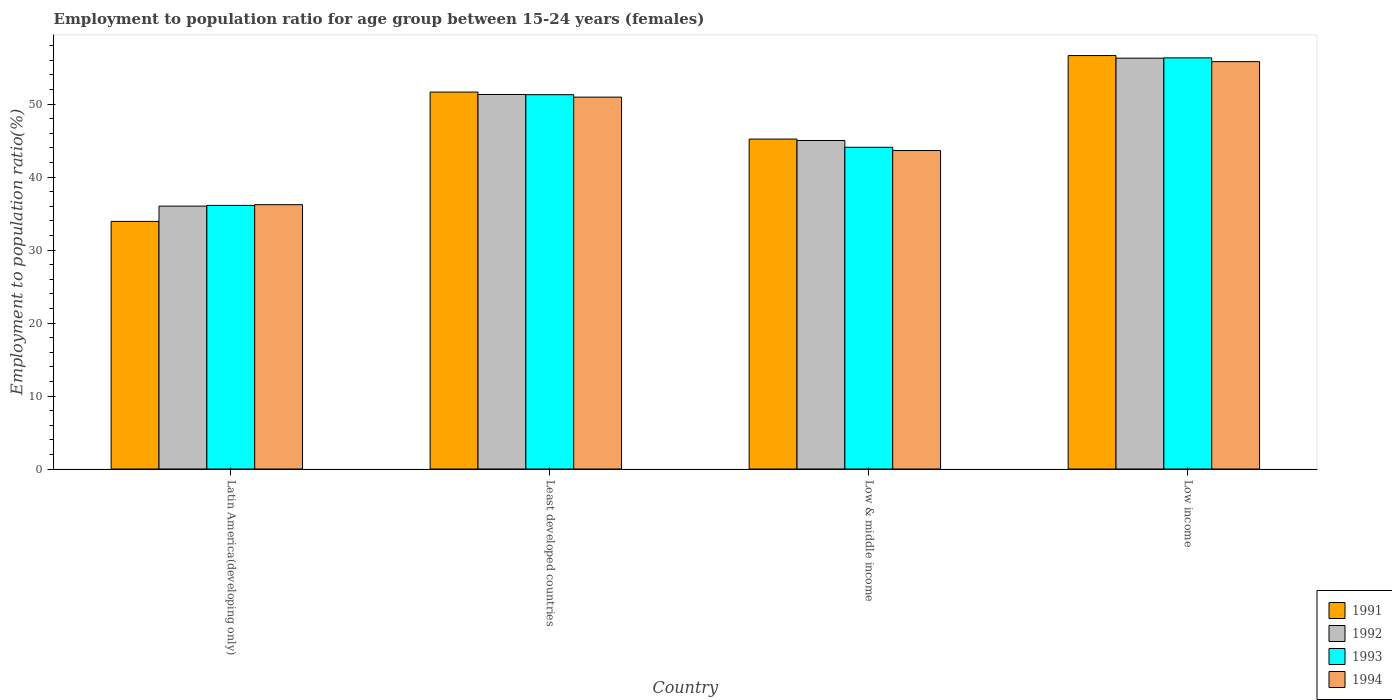What is the label of the 1st group of bars from the left?
Make the answer very short. Latin America(developing only). What is the employment to population ratio in 1993 in Low income?
Provide a succinct answer. 56.33. Across all countries, what is the maximum employment to population ratio in 1994?
Make the answer very short. 55.82. Across all countries, what is the minimum employment to population ratio in 1994?
Your answer should be compact. 36.22. In which country was the employment to population ratio in 1992 maximum?
Your answer should be compact. Low income. In which country was the employment to population ratio in 1994 minimum?
Your answer should be compact. Latin America(developing only). What is the total employment to population ratio in 1994 in the graph?
Offer a terse response. 186.64. What is the difference between the employment to population ratio in 1991 in Latin America(developing only) and that in Low income?
Give a very brief answer. -22.73. What is the difference between the employment to population ratio in 1994 in Least developed countries and the employment to population ratio in 1992 in Latin America(developing only)?
Your answer should be very brief. 14.93. What is the average employment to population ratio in 1993 per country?
Offer a terse response. 46.96. What is the difference between the employment to population ratio of/in 1992 and employment to population ratio of/in 1994 in Low income?
Provide a short and direct response. 0.47. What is the ratio of the employment to population ratio in 1994 in Latin America(developing only) to that in Low & middle income?
Your response must be concise. 0.83. Is the employment to population ratio in 1991 in Low & middle income less than that in Low income?
Offer a very short reply. Yes. What is the difference between the highest and the second highest employment to population ratio in 1994?
Make the answer very short. 7.31. What is the difference between the highest and the lowest employment to population ratio in 1991?
Offer a very short reply. 22.73. In how many countries, is the employment to population ratio in 1991 greater than the average employment to population ratio in 1991 taken over all countries?
Your answer should be compact. 2. What does the 4th bar from the left in Low income represents?
Ensure brevity in your answer.  1994. How many bars are there?
Give a very brief answer. 16. Are all the bars in the graph horizontal?
Offer a terse response. No. What is the difference between two consecutive major ticks on the Y-axis?
Give a very brief answer. 10. Are the values on the major ticks of Y-axis written in scientific E-notation?
Give a very brief answer. No. Does the graph contain any zero values?
Offer a terse response. No. Where does the legend appear in the graph?
Ensure brevity in your answer.  Bottom right. How are the legend labels stacked?
Your answer should be compact. Vertical. What is the title of the graph?
Offer a terse response. Employment to population ratio for age group between 15-24 years (females). What is the Employment to population ratio(%) of 1991 in Latin America(developing only)?
Offer a very short reply. 33.93. What is the Employment to population ratio(%) in 1992 in Latin America(developing only)?
Ensure brevity in your answer.  36.02. What is the Employment to population ratio(%) of 1993 in Latin America(developing only)?
Provide a short and direct response. 36.12. What is the Employment to population ratio(%) in 1994 in Latin America(developing only)?
Give a very brief answer. 36.22. What is the Employment to population ratio(%) in 1991 in Least developed countries?
Ensure brevity in your answer.  51.65. What is the Employment to population ratio(%) in 1992 in Least developed countries?
Your answer should be very brief. 51.32. What is the Employment to population ratio(%) of 1993 in Least developed countries?
Provide a succinct answer. 51.29. What is the Employment to population ratio(%) of 1994 in Least developed countries?
Keep it short and to the point. 50.95. What is the Employment to population ratio(%) of 1991 in Low & middle income?
Make the answer very short. 45.21. What is the Employment to population ratio(%) in 1992 in Low & middle income?
Your response must be concise. 45.01. What is the Employment to population ratio(%) of 1993 in Low & middle income?
Provide a short and direct response. 44.08. What is the Employment to population ratio(%) in 1994 in Low & middle income?
Offer a terse response. 43.64. What is the Employment to population ratio(%) of 1991 in Low income?
Make the answer very short. 56.65. What is the Employment to population ratio(%) of 1992 in Low income?
Give a very brief answer. 56.29. What is the Employment to population ratio(%) in 1993 in Low income?
Your answer should be very brief. 56.33. What is the Employment to population ratio(%) in 1994 in Low income?
Make the answer very short. 55.82. Across all countries, what is the maximum Employment to population ratio(%) of 1991?
Offer a terse response. 56.65. Across all countries, what is the maximum Employment to population ratio(%) in 1992?
Give a very brief answer. 56.29. Across all countries, what is the maximum Employment to population ratio(%) in 1993?
Provide a succinct answer. 56.33. Across all countries, what is the maximum Employment to population ratio(%) of 1994?
Offer a very short reply. 55.82. Across all countries, what is the minimum Employment to population ratio(%) in 1991?
Keep it short and to the point. 33.93. Across all countries, what is the minimum Employment to population ratio(%) in 1992?
Ensure brevity in your answer.  36.02. Across all countries, what is the minimum Employment to population ratio(%) in 1993?
Your response must be concise. 36.12. Across all countries, what is the minimum Employment to population ratio(%) of 1994?
Offer a very short reply. 36.22. What is the total Employment to population ratio(%) of 1991 in the graph?
Keep it short and to the point. 187.44. What is the total Employment to population ratio(%) in 1992 in the graph?
Give a very brief answer. 188.65. What is the total Employment to population ratio(%) of 1993 in the graph?
Provide a succinct answer. 187.83. What is the total Employment to population ratio(%) of 1994 in the graph?
Give a very brief answer. 186.64. What is the difference between the Employment to population ratio(%) of 1991 in Latin America(developing only) and that in Least developed countries?
Give a very brief answer. -17.73. What is the difference between the Employment to population ratio(%) in 1992 in Latin America(developing only) and that in Least developed countries?
Ensure brevity in your answer.  -15.29. What is the difference between the Employment to population ratio(%) in 1993 in Latin America(developing only) and that in Least developed countries?
Make the answer very short. -15.17. What is the difference between the Employment to population ratio(%) of 1994 in Latin America(developing only) and that in Least developed countries?
Give a very brief answer. -14.73. What is the difference between the Employment to population ratio(%) of 1991 in Latin America(developing only) and that in Low & middle income?
Ensure brevity in your answer.  -11.28. What is the difference between the Employment to population ratio(%) of 1992 in Latin America(developing only) and that in Low & middle income?
Make the answer very short. -8.99. What is the difference between the Employment to population ratio(%) in 1993 in Latin America(developing only) and that in Low & middle income?
Your answer should be compact. -7.96. What is the difference between the Employment to population ratio(%) of 1994 in Latin America(developing only) and that in Low & middle income?
Give a very brief answer. -7.42. What is the difference between the Employment to population ratio(%) of 1991 in Latin America(developing only) and that in Low income?
Provide a short and direct response. -22.73. What is the difference between the Employment to population ratio(%) of 1992 in Latin America(developing only) and that in Low income?
Provide a short and direct response. -20.27. What is the difference between the Employment to population ratio(%) of 1993 in Latin America(developing only) and that in Low income?
Keep it short and to the point. -20.22. What is the difference between the Employment to population ratio(%) of 1994 in Latin America(developing only) and that in Low income?
Ensure brevity in your answer.  -19.6. What is the difference between the Employment to population ratio(%) of 1991 in Least developed countries and that in Low & middle income?
Give a very brief answer. 6.44. What is the difference between the Employment to population ratio(%) in 1992 in Least developed countries and that in Low & middle income?
Offer a very short reply. 6.3. What is the difference between the Employment to population ratio(%) in 1993 in Least developed countries and that in Low & middle income?
Offer a very short reply. 7.21. What is the difference between the Employment to population ratio(%) in 1994 in Least developed countries and that in Low & middle income?
Keep it short and to the point. 7.31. What is the difference between the Employment to population ratio(%) of 1991 in Least developed countries and that in Low income?
Keep it short and to the point. -5. What is the difference between the Employment to population ratio(%) in 1992 in Least developed countries and that in Low income?
Ensure brevity in your answer.  -4.98. What is the difference between the Employment to population ratio(%) of 1993 in Least developed countries and that in Low income?
Your answer should be compact. -5.04. What is the difference between the Employment to population ratio(%) of 1994 in Least developed countries and that in Low income?
Provide a succinct answer. -4.87. What is the difference between the Employment to population ratio(%) in 1991 in Low & middle income and that in Low income?
Ensure brevity in your answer.  -11.44. What is the difference between the Employment to population ratio(%) in 1992 in Low & middle income and that in Low income?
Your response must be concise. -11.28. What is the difference between the Employment to population ratio(%) in 1993 in Low & middle income and that in Low income?
Your response must be concise. -12.25. What is the difference between the Employment to population ratio(%) in 1994 in Low & middle income and that in Low income?
Offer a terse response. -12.18. What is the difference between the Employment to population ratio(%) in 1991 in Latin America(developing only) and the Employment to population ratio(%) in 1992 in Least developed countries?
Offer a terse response. -17.39. What is the difference between the Employment to population ratio(%) of 1991 in Latin America(developing only) and the Employment to population ratio(%) of 1993 in Least developed countries?
Your answer should be very brief. -17.37. What is the difference between the Employment to population ratio(%) in 1991 in Latin America(developing only) and the Employment to population ratio(%) in 1994 in Least developed countries?
Ensure brevity in your answer.  -17.03. What is the difference between the Employment to population ratio(%) in 1992 in Latin America(developing only) and the Employment to population ratio(%) in 1993 in Least developed countries?
Your answer should be compact. -15.27. What is the difference between the Employment to population ratio(%) of 1992 in Latin America(developing only) and the Employment to population ratio(%) of 1994 in Least developed countries?
Provide a short and direct response. -14.93. What is the difference between the Employment to population ratio(%) in 1993 in Latin America(developing only) and the Employment to population ratio(%) in 1994 in Least developed countries?
Your response must be concise. -14.84. What is the difference between the Employment to population ratio(%) of 1991 in Latin America(developing only) and the Employment to population ratio(%) of 1992 in Low & middle income?
Keep it short and to the point. -11.09. What is the difference between the Employment to population ratio(%) of 1991 in Latin America(developing only) and the Employment to population ratio(%) of 1993 in Low & middle income?
Your answer should be very brief. -10.16. What is the difference between the Employment to population ratio(%) in 1991 in Latin America(developing only) and the Employment to population ratio(%) in 1994 in Low & middle income?
Offer a very short reply. -9.71. What is the difference between the Employment to population ratio(%) of 1992 in Latin America(developing only) and the Employment to population ratio(%) of 1993 in Low & middle income?
Give a very brief answer. -8.06. What is the difference between the Employment to population ratio(%) in 1992 in Latin America(developing only) and the Employment to population ratio(%) in 1994 in Low & middle income?
Keep it short and to the point. -7.62. What is the difference between the Employment to population ratio(%) of 1993 in Latin America(developing only) and the Employment to population ratio(%) of 1994 in Low & middle income?
Your response must be concise. -7.52. What is the difference between the Employment to population ratio(%) of 1991 in Latin America(developing only) and the Employment to population ratio(%) of 1992 in Low income?
Your response must be concise. -22.37. What is the difference between the Employment to population ratio(%) of 1991 in Latin America(developing only) and the Employment to population ratio(%) of 1993 in Low income?
Your answer should be very brief. -22.41. What is the difference between the Employment to population ratio(%) in 1991 in Latin America(developing only) and the Employment to population ratio(%) in 1994 in Low income?
Offer a terse response. -21.9. What is the difference between the Employment to population ratio(%) of 1992 in Latin America(developing only) and the Employment to population ratio(%) of 1993 in Low income?
Ensure brevity in your answer.  -20.31. What is the difference between the Employment to population ratio(%) in 1992 in Latin America(developing only) and the Employment to population ratio(%) in 1994 in Low income?
Provide a succinct answer. -19.8. What is the difference between the Employment to population ratio(%) of 1993 in Latin America(developing only) and the Employment to population ratio(%) of 1994 in Low income?
Give a very brief answer. -19.7. What is the difference between the Employment to population ratio(%) in 1991 in Least developed countries and the Employment to population ratio(%) in 1992 in Low & middle income?
Keep it short and to the point. 6.64. What is the difference between the Employment to population ratio(%) of 1991 in Least developed countries and the Employment to population ratio(%) of 1993 in Low & middle income?
Offer a very short reply. 7.57. What is the difference between the Employment to population ratio(%) of 1991 in Least developed countries and the Employment to population ratio(%) of 1994 in Low & middle income?
Offer a very short reply. 8.01. What is the difference between the Employment to population ratio(%) in 1992 in Least developed countries and the Employment to population ratio(%) in 1993 in Low & middle income?
Make the answer very short. 7.23. What is the difference between the Employment to population ratio(%) in 1992 in Least developed countries and the Employment to population ratio(%) in 1994 in Low & middle income?
Provide a short and direct response. 7.68. What is the difference between the Employment to population ratio(%) in 1993 in Least developed countries and the Employment to population ratio(%) in 1994 in Low & middle income?
Your answer should be very brief. 7.65. What is the difference between the Employment to population ratio(%) in 1991 in Least developed countries and the Employment to population ratio(%) in 1992 in Low income?
Offer a very short reply. -4.64. What is the difference between the Employment to population ratio(%) in 1991 in Least developed countries and the Employment to population ratio(%) in 1993 in Low income?
Keep it short and to the point. -4.68. What is the difference between the Employment to population ratio(%) in 1991 in Least developed countries and the Employment to population ratio(%) in 1994 in Low income?
Ensure brevity in your answer.  -4.17. What is the difference between the Employment to population ratio(%) of 1992 in Least developed countries and the Employment to population ratio(%) of 1993 in Low income?
Make the answer very short. -5.02. What is the difference between the Employment to population ratio(%) in 1992 in Least developed countries and the Employment to population ratio(%) in 1994 in Low income?
Ensure brevity in your answer.  -4.51. What is the difference between the Employment to population ratio(%) of 1993 in Least developed countries and the Employment to population ratio(%) of 1994 in Low income?
Offer a terse response. -4.53. What is the difference between the Employment to population ratio(%) in 1991 in Low & middle income and the Employment to population ratio(%) in 1992 in Low income?
Your response must be concise. -11.09. What is the difference between the Employment to population ratio(%) of 1991 in Low & middle income and the Employment to population ratio(%) of 1993 in Low income?
Provide a succinct answer. -11.13. What is the difference between the Employment to population ratio(%) in 1991 in Low & middle income and the Employment to population ratio(%) in 1994 in Low income?
Offer a terse response. -10.61. What is the difference between the Employment to population ratio(%) of 1992 in Low & middle income and the Employment to population ratio(%) of 1993 in Low income?
Offer a terse response. -11.32. What is the difference between the Employment to population ratio(%) of 1992 in Low & middle income and the Employment to population ratio(%) of 1994 in Low income?
Ensure brevity in your answer.  -10.81. What is the difference between the Employment to population ratio(%) of 1993 in Low & middle income and the Employment to population ratio(%) of 1994 in Low income?
Keep it short and to the point. -11.74. What is the average Employment to population ratio(%) of 1991 per country?
Keep it short and to the point. 46.86. What is the average Employment to population ratio(%) of 1992 per country?
Provide a succinct answer. 47.16. What is the average Employment to population ratio(%) in 1993 per country?
Offer a terse response. 46.96. What is the average Employment to population ratio(%) in 1994 per country?
Offer a terse response. 46.66. What is the difference between the Employment to population ratio(%) in 1991 and Employment to population ratio(%) in 1992 in Latin America(developing only)?
Your answer should be compact. -2.1. What is the difference between the Employment to population ratio(%) in 1991 and Employment to population ratio(%) in 1993 in Latin America(developing only)?
Your answer should be very brief. -2.19. What is the difference between the Employment to population ratio(%) in 1991 and Employment to population ratio(%) in 1994 in Latin America(developing only)?
Your answer should be compact. -2.3. What is the difference between the Employment to population ratio(%) of 1992 and Employment to population ratio(%) of 1993 in Latin America(developing only)?
Keep it short and to the point. -0.09. What is the difference between the Employment to population ratio(%) in 1992 and Employment to population ratio(%) in 1994 in Latin America(developing only)?
Offer a terse response. -0.2. What is the difference between the Employment to population ratio(%) of 1993 and Employment to population ratio(%) of 1994 in Latin America(developing only)?
Offer a very short reply. -0.1. What is the difference between the Employment to population ratio(%) in 1991 and Employment to population ratio(%) in 1992 in Least developed countries?
Your answer should be very brief. 0.33. What is the difference between the Employment to population ratio(%) of 1991 and Employment to population ratio(%) of 1993 in Least developed countries?
Provide a short and direct response. 0.36. What is the difference between the Employment to population ratio(%) in 1991 and Employment to population ratio(%) in 1994 in Least developed countries?
Make the answer very short. 0.7. What is the difference between the Employment to population ratio(%) in 1992 and Employment to population ratio(%) in 1993 in Least developed countries?
Your response must be concise. 0.03. What is the difference between the Employment to population ratio(%) in 1992 and Employment to population ratio(%) in 1994 in Least developed countries?
Keep it short and to the point. 0.36. What is the difference between the Employment to population ratio(%) in 1993 and Employment to population ratio(%) in 1994 in Least developed countries?
Keep it short and to the point. 0.34. What is the difference between the Employment to population ratio(%) of 1991 and Employment to population ratio(%) of 1992 in Low & middle income?
Keep it short and to the point. 0.2. What is the difference between the Employment to population ratio(%) of 1991 and Employment to population ratio(%) of 1993 in Low & middle income?
Keep it short and to the point. 1.13. What is the difference between the Employment to population ratio(%) of 1991 and Employment to population ratio(%) of 1994 in Low & middle income?
Make the answer very short. 1.57. What is the difference between the Employment to population ratio(%) in 1992 and Employment to population ratio(%) in 1993 in Low & middle income?
Give a very brief answer. 0.93. What is the difference between the Employment to population ratio(%) of 1992 and Employment to population ratio(%) of 1994 in Low & middle income?
Provide a succinct answer. 1.37. What is the difference between the Employment to population ratio(%) of 1993 and Employment to population ratio(%) of 1994 in Low & middle income?
Offer a terse response. 0.44. What is the difference between the Employment to population ratio(%) of 1991 and Employment to population ratio(%) of 1992 in Low income?
Offer a very short reply. 0.36. What is the difference between the Employment to population ratio(%) of 1991 and Employment to population ratio(%) of 1993 in Low income?
Provide a succinct answer. 0.32. What is the difference between the Employment to population ratio(%) of 1991 and Employment to population ratio(%) of 1994 in Low income?
Give a very brief answer. 0.83. What is the difference between the Employment to population ratio(%) of 1992 and Employment to population ratio(%) of 1993 in Low income?
Keep it short and to the point. -0.04. What is the difference between the Employment to population ratio(%) in 1992 and Employment to population ratio(%) in 1994 in Low income?
Your answer should be compact. 0.47. What is the difference between the Employment to population ratio(%) of 1993 and Employment to population ratio(%) of 1994 in Low income?
Ensure brevity in your answer.  0.51. What is the ratio of the Employment to population ratio(%) of 1991 in Latin America(developing only) to that in Least developed countries?
Your answer should be compact. 0.66. What is the ratio of the Employment to population ratio(%) in 1992 in Latin America(developing only) to that in Least developed countries?
Offer a very short reply. 0.7. What is the ratio of the Employment to population ratio(%) in 1993 in Latin America(developing only) to that in Least developed countries?
Offer a terse response. 0.7. What is the ratio of the Employment to population ratio(%) of 1994 in Latin America(developing only) to that in Least developed countries?
Offer a very short reply. 0.71. What is the ratio of the Employment to population ratio(%) in 1991 in Latin America(developing only) to that in Low & middle income?
Your answer should be compact. 0.75. What is the ratio of the Employment to population ratio(%) in 1992 in Latin America(developing only) to that in Low & middle income?
Your answer should be very brief. 0.8. What is the ratio of the Employment to population ratio(%) of 1993 in Latin America(developing only) to that in Low & middle income?
Keep it short and to the point. 0.82. What is the ratio of the Employment to population ratio(%) in 1994 in Latin America(developing only) to that in Low & middle income?
Provide a short and direct response. 0.83. What is the ratio of the Employment to population ratio(%) in 1991 in Latin America(developing only) to that in Low income?
Provide a short and direct response. 0.6. What is the ratio of the Employment to population ratio(%) of 1992 in Latin America(developing only) to that in Low income?
Provide a short and direct response. 0.64. What is the ratio of the Employment to population ratio(%) of 1993 in Latin America(developing only) to that in Low income?
Your answer should be very brief. 0.64. What is the ratio of the Employment to population ratio(%) in 1994 in Latin America(developing only) to that in Low income?
Your answer should be very brief. 0.65. What is the ratio of the Employment to population ratio(%) of 1991 in Least developed countries to that in Low & middle income?
Your response must be concise. 1.14. What is the ratio of the Employment to population ratio(%) of 1992 in Least developed countries to that in Low & middle income?
Keep it short and to the point. 1.14. What is the ratio of the Employment to population ratio(%) in 1993 in Least developed countries to that in Low & middle income?
Ensure brevity in your answer.  1.16. What is the ratio of the Employment to population ratio(%) of 1994 in Least developed countries to that in Low & middle income?
Your response must be concise. 1.17. What is the ratio of the Employment to population ratio(%) of 1991 in Least developed countries to that in Low income?
Provide a succinct answer. 0.91. What is the ratio of the Employment to population ratio(%) of 1992 in Least developed countries to that in Low income?
Ensure brevity in your answer.  0.91. What is the ratio of the Employment to population ratio(%) of 1993 in Least developed countries to that in Low income?
Offer a terse response. 0.91. What is the ratio of the Employment to population ratio(%) in 1994 in Least developed countries to that in Low income?
Offer a terse response. 0.91. What is the ratio of the Employment to population ratio(%) of 1991 in Low & middle income to that in Low income?
Keep it short and to the point. 0.8. What is the ratio of the Employment to population ratio(%) of 1992 in Low & middle income to that in Low income?
Provide a short and direct response. 0.8. What is the ratio of the Employment to population ratio(%) in 1993 in Low & middle income to that in Low income?
Keep it short and to the point. 0.78. What is the ratio of the Employment to population ratio(%) of 1994 in Low & middle income to that in Low income?
Give a very brief answer. 0.78. What is the difference between the highest and the second highest Employment to population ratio(%) in 1991?
Your response must be concise. 5. What is the difference between the highest and the second highest Employment to population ratio(%) in 1992?
Offer a terse response. 4.98. What is the difference between the highest and the second highest Employment to population ratio(%) in 1993?
Give a very brief answer. 5.04. What is the difference between the highest and the second highest Employment to population ratio(%) of 1994?
Your answer should be very brief. 4.87. What is the difference between the highest and the lowest Employment to population ratio(%) in 1991?
Your answer should be very brief. 22.73. What is the difference between the highest and the lowest Employment to population ratio(%) in 1992?
Your response must be concise. 20.27. What is the difference between the highest and the lowest Employment to population ratio(%) in 1993?
Make the answer very short. 20.22. What is the difference between the highest and the lowest Employment to population ratio(%) of 1994?
Ensure brevity in your answer.  19.6. 